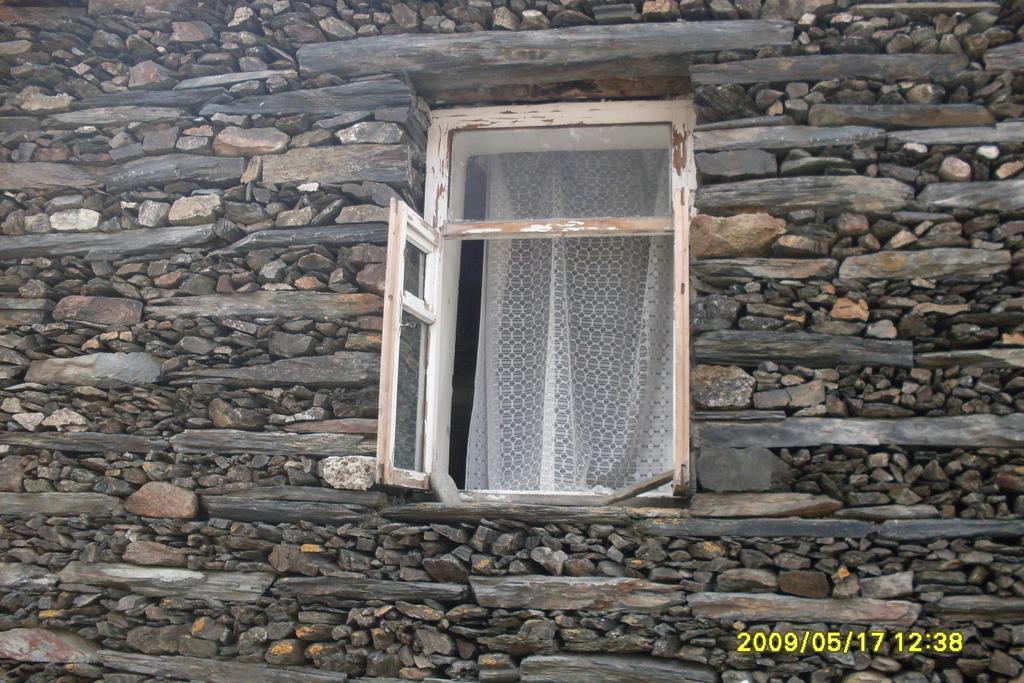Can you describe this image briefly? In the image we can see there is a window on the wall and the wall is made up of stones. There are curtains on the window. 